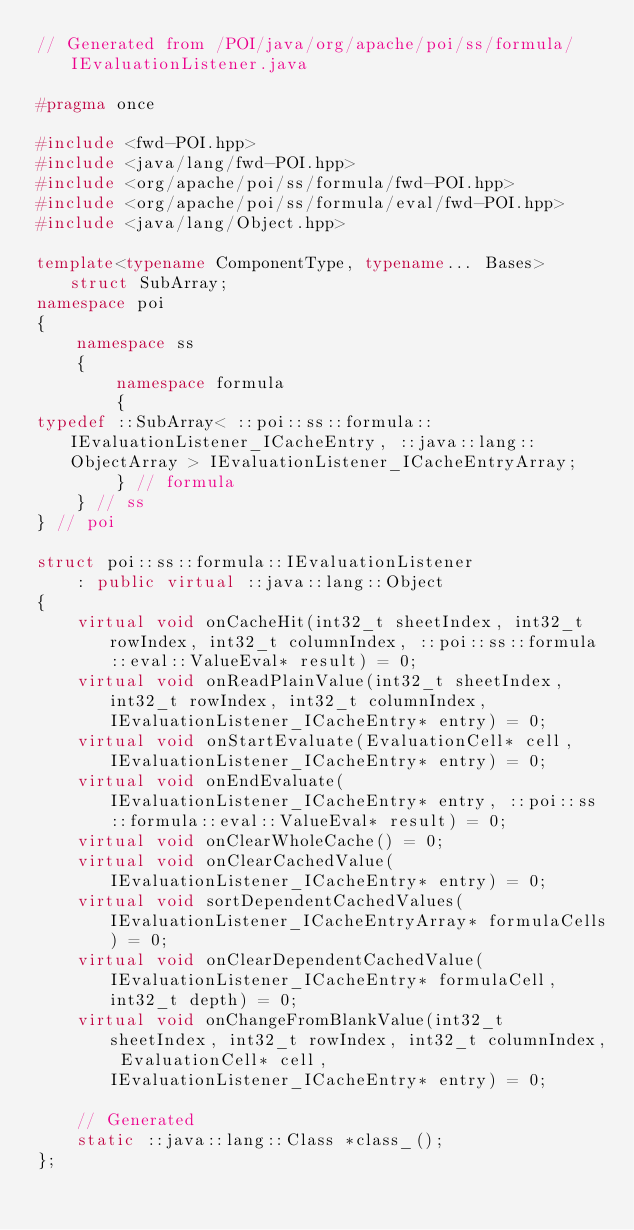<code> <loc_0><loc_0><loc_500><loc_500><_C++_>// Generated from /POI/java/org/apache/poi/ss/formula/IEvaluationListener.java

#pragma once

#include <fwd-POI.hpp>
#include <java/lang/fwd-POI.hpp>
#include <org/apache/poi/ss/formula/fwd-POI.hpp>
#include <org/apache/poi/ss/formula/eval/fwd-POI.hpp>
#include <java/lang/Object.hpp>

template<typename ComponentType, typename... Bases> struct SubArray;
namespace poi
{
    namespace ss
    {
        namespace formula
        {
typedef ::SubArray< ::poi::ss::formula::IEvaluationListener_ICacheEntry, ::java::lang::ObjectArray > IEvaluationListener_ICacheEntryArray;
        } // formula
    } // ss
} // poi

struct poi::ss::formula::IEvaluationListener
    : public virtual ::java::lang::Object
{
    virtual void onCacheHit(int32_t sheetIndex, int32_t rowIndex, int32_t columnIndex, ::poi::ss::formula::eval::ValueEval* result) = 0;
    virtual void onReadPlainValue(int32_t sheetIndex, int32_t rowIndex, int32_t columnIndex, IEvaluationListener_ICacheEntry* entry) = 0;
    virtual void onStartEvaluate(EvaluationCell* cell, IEvaluationListener_ICacheEntry* entry) = 0;
    virtual void onEndEvaluate(IEvaluationListener_ICacheEntry* entry, ::poi::ss::formula::eval::ValueEval* result) = 0;
    virtual void onClearWholeCache() = 0;
    virtual void onClearCachedValue(IEvaluationListener_ICacheEntry* entry) = 0;
    virtual void sortDependentCachedValues(IEvaluationListener_ICacheEntryArray* formulaCells) = 0;
    virtual void onClearDependentCachedValue(IEvaluationListener_ICacheEntry* formulaCell, int32_t depth) = 0;
    virtual void onChangeFromBlankValue(int32_t sheetIndex, int32_t rowIndex, int32_t columnIndex, EvaluationCell* cell, IEvaluationListener_ICacheEntry* entry) = 0;

    // Generated
    static ::java::lang::Class *class_();
};
</code> 